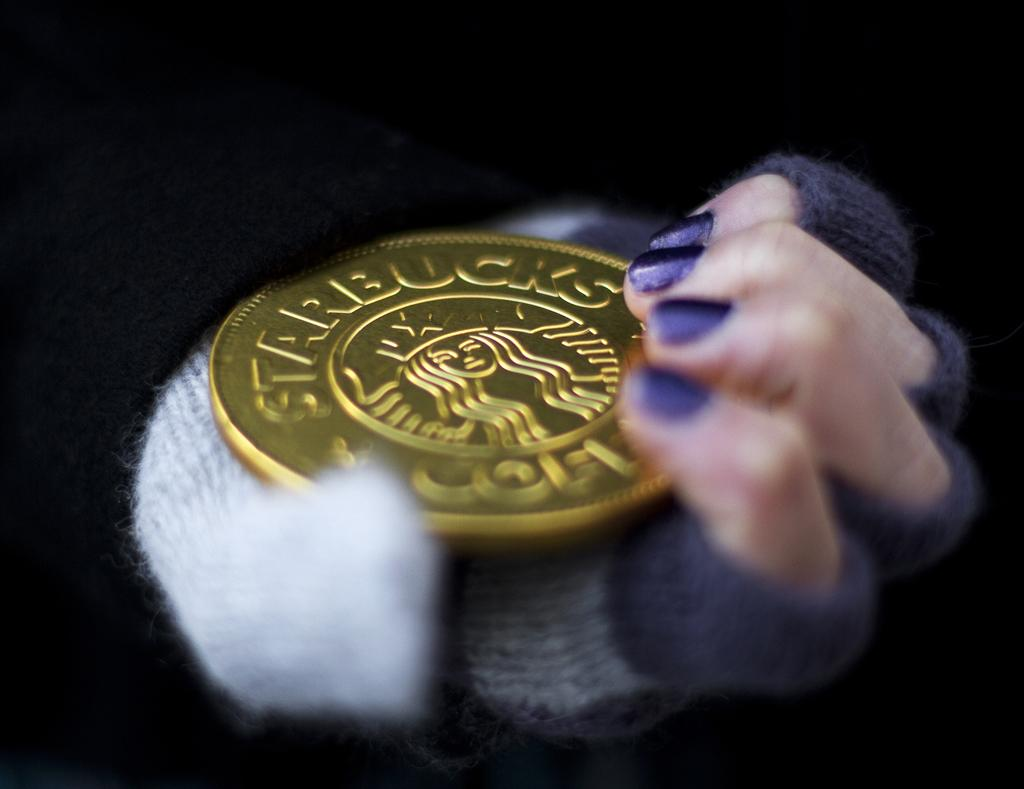<image>
Describe the image concisely. A person holds a Starbucks chocolate coin in their hand. 